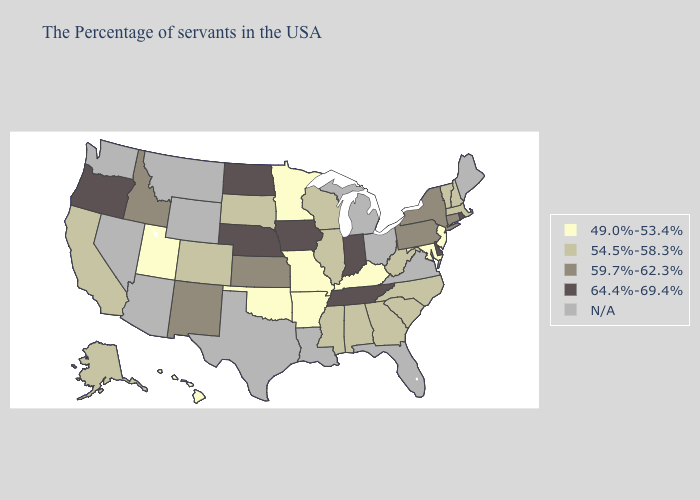Among the states that border Arkansas , does Tennessee have the highest value?
Write a very short answer. Yes. What is the value of Alabama?
Give a very brief answer. 54.5%-58.3%. Name the states that have a value in the range 64.4%-69.4%?
Answer briefly. Rhode Island, Delaware, Indiana, Tennessee, Iowa, Nebraska, North Dakota, Oregon. Does the map have missing data?
Be succinct. Yes. Among the states that border Maryland , does Pennsylvania have the highest value?
Write a very short answer. No. What is the highest value in the West ?
Give a very brief answer. 64.4%-69.4%. Which states have the lowest value in the Northeast?
Write a very short answer. New Jersey. What is the lowest value in states that border Colorado?
Answer briefly. 49.0%-53.4%. Name the states that have a value in the range 49.0%-53.4%?
Concise answer only. New Jersey, Maryland, Kentucky, Missouri, Arkansas, Minnesota, Oklahoma, Utah, Hawaii. What is the value of North Carolina?
Short answer required. 54.5%-58.3%. Name the states that have a value in the range 59.7%-62.3%?
Short answer required. Connecticut, New York, Pennsylvania, Kansas, New Mexico, Idaho. Does the map have missing data?
Give a very brief answer. Yes. Name the states that have a value in the range 49.0%-53.4%?
Quick response, please. New Jersey, Maryland, Kentucky, Missouri, Arkansas, Minnesota, Oklahoma, Utah, Hawaii. Does the map have missing data?
Write a very short answer. Yes. Name the states that have a value in the range 64.4%-69.4%?
Short answer required. Rhode Island, Delaware, Indiana, Tennessee, Iowa, Nebraska, North Dakota, Oregon. 